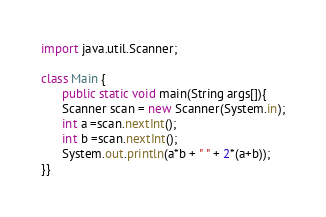Convert code to text. <code><loc_0><loc_0><loc_500><loc_500><_Java_>import java.util.Scanner;

class Main {
      public static void main(String args[]){
      Scanner scan = new Scanner(System.in);
      int a =scan.nextInt(); 
      int b =scan.nextInt();    
      System.out.println(a*b + " " + 2*(a+b));
}}
</code> 